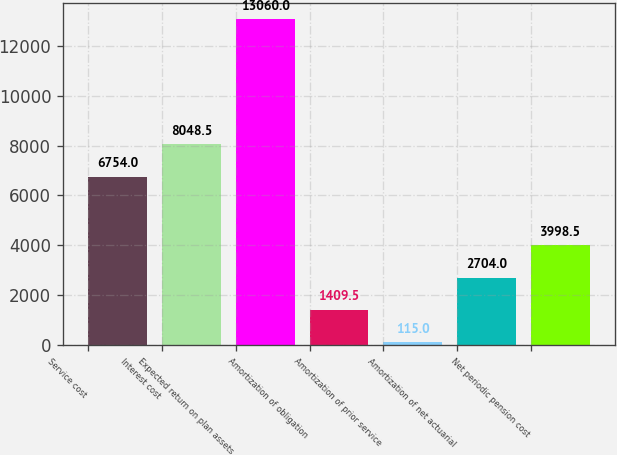Convert chart to OTSL. <chart><loc_0><loc_0><loc_500><loc_500><bar_chart><fcel>Service cost<fcel>Interest cost<fcel>Expected return on plan assets<fcel>Amortization of obligation<fcel>Amortization of prior service<fcel>Amortization of net actuarial<fcel>Net periodic pension cost<nl><fcel>6754<fcel>8048.5<fcel>13060<fcel>1409.5<fcel>115<fcel>2704<fcel>3998.5<nl></chart> 